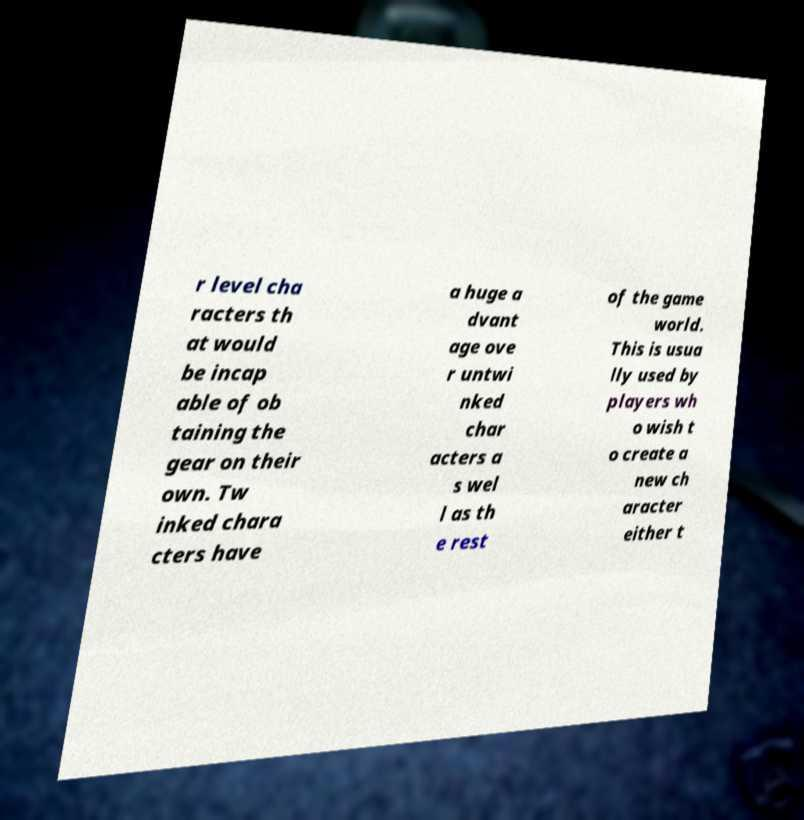Please read and relay the text visible in this image. What does it say? r level cha racters th at would be incap able of ob taining the gear on their own. Tw inked chara cters have a huge a dvant age ove r untwi nked char acters a s wel l as th e rest of the game world. This is usua lly used by players wh o wish t o create a new ch aracter either t 